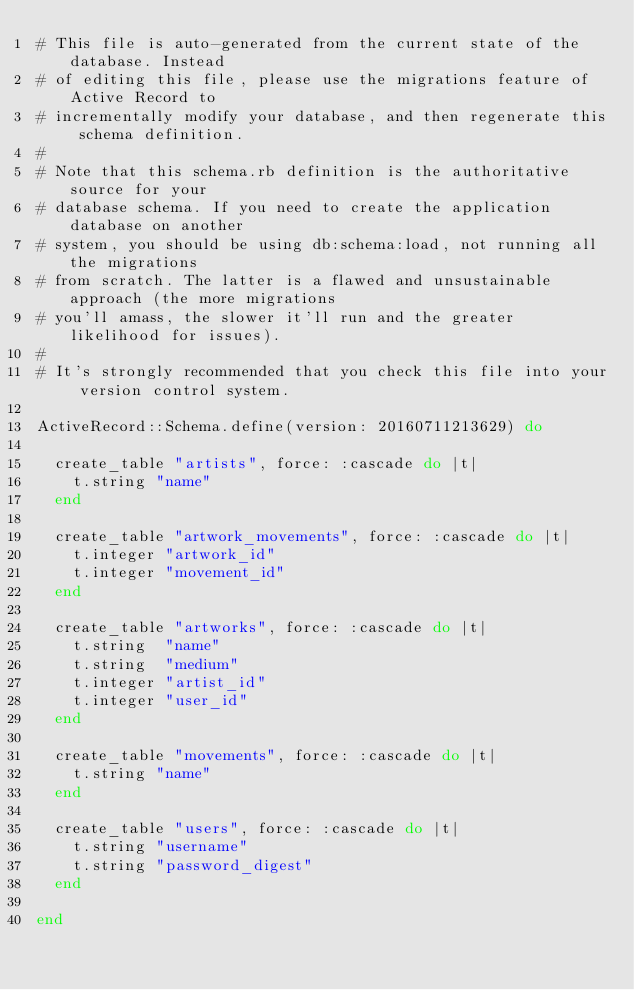Convert code to text. <code><loc_0><loc_0><loc_500><loc_500><_Ruby_># This file is auto-generated from the current state of the database. Instead
# of editing this file, please use the migrations feature of Active Record to
# incrementally modify your database, and then regenerate this schema definition.
#
# Note that this schema.rb definition is the authoritative source for your
# database schema. If you need to create the application database on another
# system, you should be using db:schema:load, not running all the migrations
# from scratch. The latter is a flawed and unsustainable approach (the more migrations
# you'll amass, the slower it'll run and the greater likelihood for issues).
#
# It's strongly recommended that you check this file into your version control system.

ActiveRecord::Schema.define(version: 20160711213629) do

  create_table "artists", force: :cascade do |t|
    t.string "name"
  end

  create_table "artwork_movements", force: :cascade do |t|
    t.integer "artwork_id"
    t.integer "movement_id"
  end

  create_table "artworks", force: :cascade do |t|
    t.string  "name"
    t.string  "medium"
    t.integer "artist_id"
    t.integer "user_id"
  end

  create_table "movements", force: :cascade do |t|
    t.string "name"
  end

  create_table "users", force: :cascade do |t|
    t.string "username"
    t.string "password_digest"
  end

end
</code> 